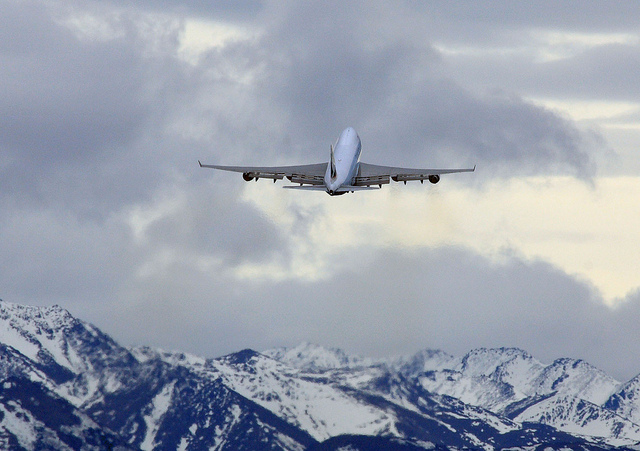Describe the landscape shown? The landscape includes a range of snow-capped mountains beneath a sky partly filled with clouds, conveying a sense of altitude and possibly cold weather conditions. 